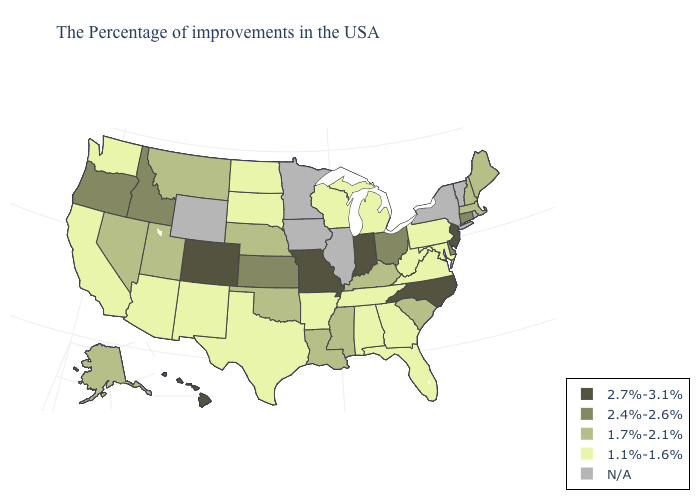Among the states that border Nevada , does Arizona have the highest value?
Answer briefly. No. What is the value of Alabama?
Concise answer only. 1.1%-1.6%. Does the first symbol in the legend represent the smallest category?
Write a very short answer. No. Name the states that have a value in the range 2.7%-3.1%?
Answer briefly. New Jersey, North Carolina, Indiana, Missouri, Colorado, Hawaii. Is the legend a continuous bar?
Give a very brief answer. No. What is the value of Florida?
Answer briefly. 1.1%-1.6%. Name the states that have a value in the range 1.7%-2.1%?
Concise answer only. Maine, Massachusetts, New Hampshire, South Carolina, Kentucky, Mississippi, Louisiana, Nebraska, Oklahoma, Utah, Montana, Nevada, Alaska. Which states hav the highest value in the Northeast?
Quick response, please. New Jersey. Name the states that have a value in the range N/A?
Quick response, please. Rhode Island, Vermont, New York, Illinois, Minnesota, Iowa, Wyoming. What is the value of Virginia?
Write a very short answer. 1.1%-1.6%. Which states have the lowest value in the USA?
Keep it brief. Maryland, Pennsylvania, Virginia, West Virginia, Florida, Georgia, Michigan, Alabama, Tennessee, Wisconsin, Arkansas, Texas, South Dakota, North Dakota, New Mexico, Arizona, California, Washington. Name the states that have a value in the range 2.4%-2.6%?
Give a very brief answer. Connecticut, Delaware, Ohio, Kansas, Idaho, Oregon. Among the states that border New York , does Pennsylvania have the lowest value?
Answer briefly. Yes. 